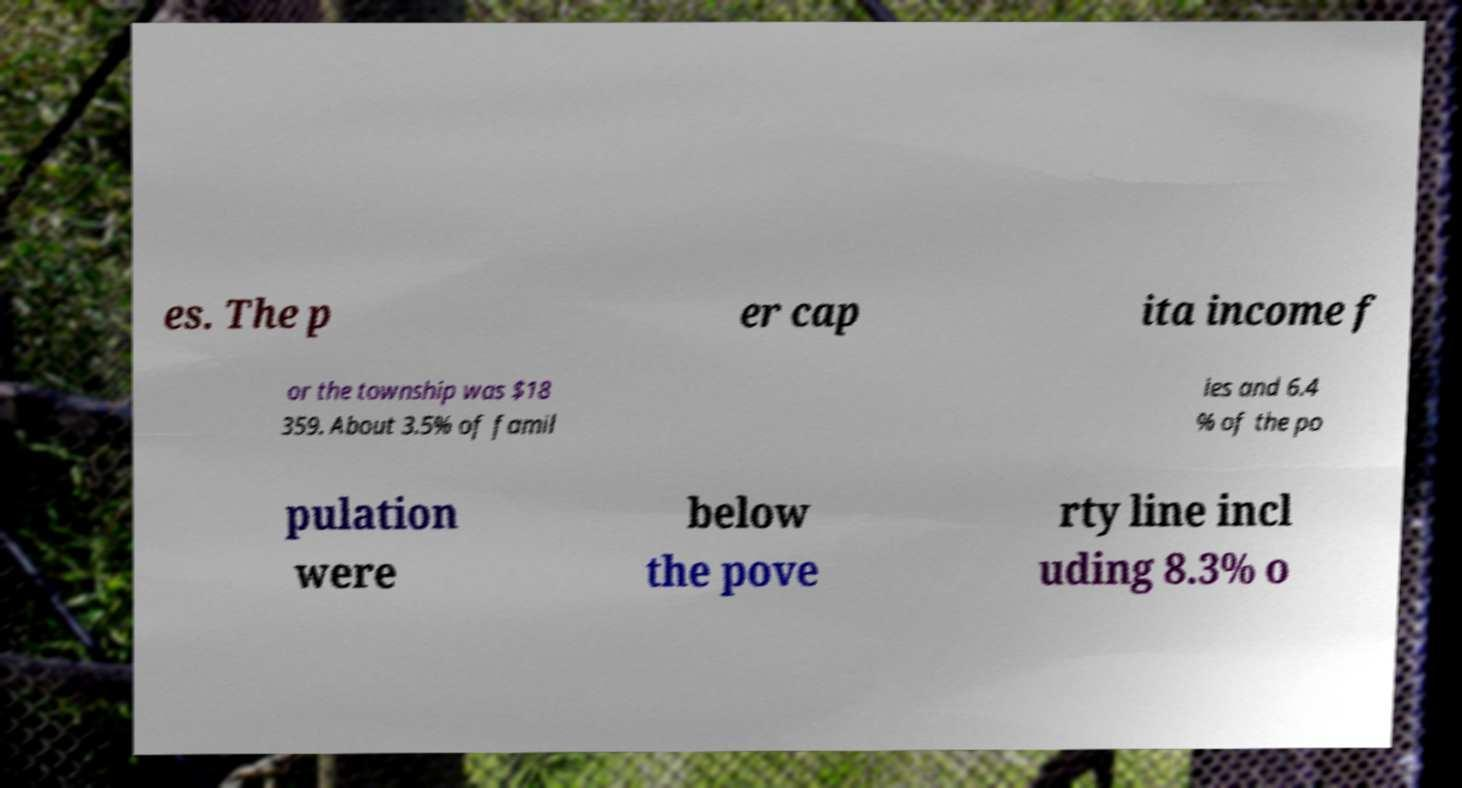Could you extract and type out the text from this image? es. The p er cap ita income f or the township was $18 359. About 3.5% of famil ies and 6.4 % of the po pulation were below the pove rty line incl uding 8.3% o 